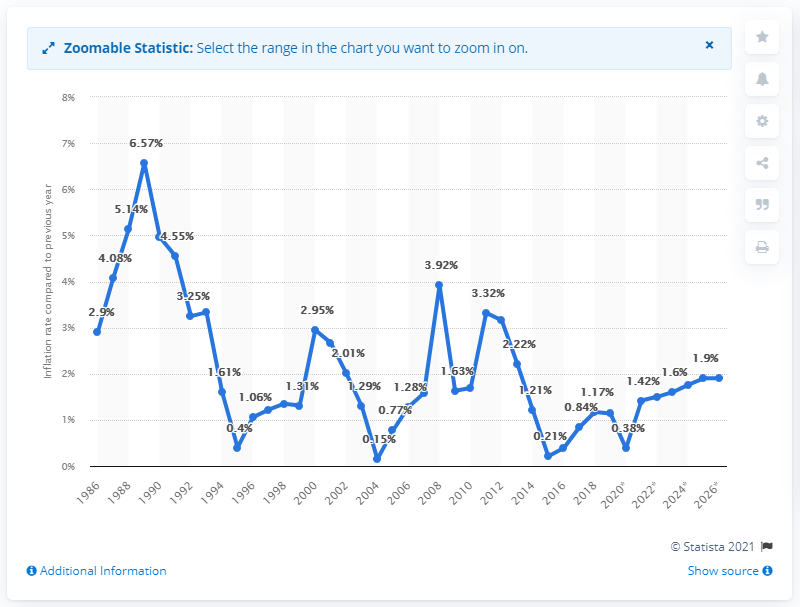Give some essential details in this illustration. In 2019, the inflation rate in Finland was 1.14%. 